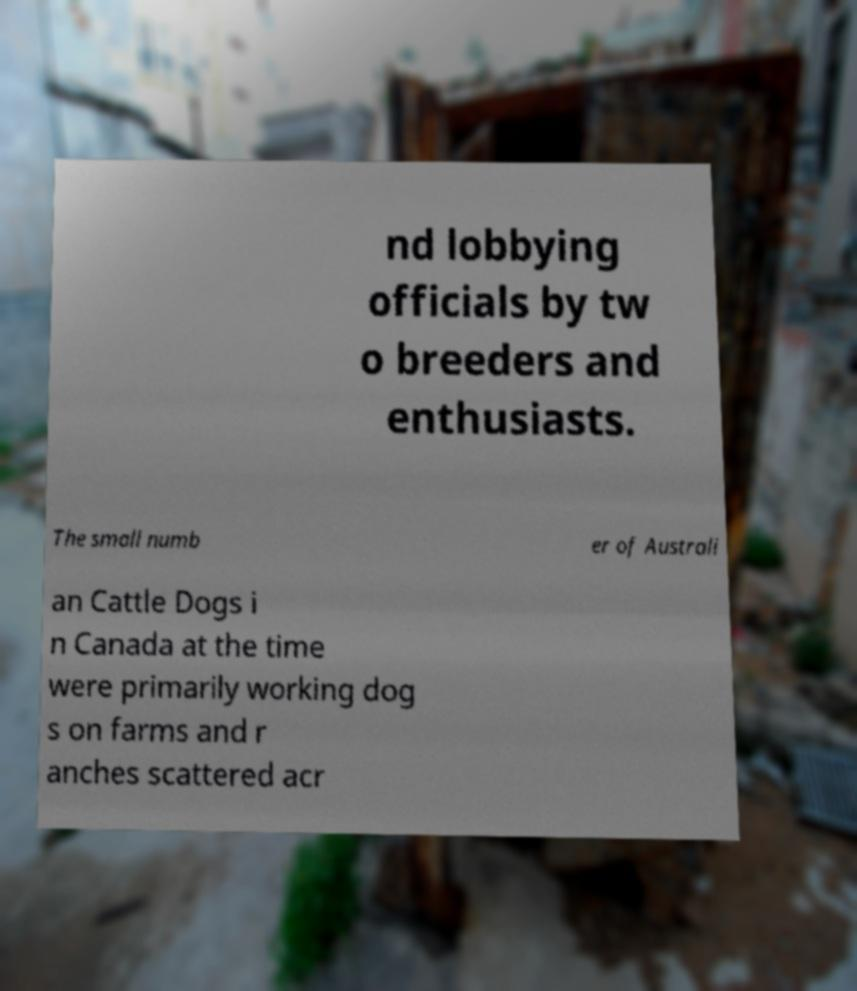What messages or text are displayed in this image? I need them in a readable, typed format. nd lobbying officials by tw o breeders and enthusiasts. The small numb er of Australi an Cattle Dogs i n Canada at the time were primarily working dog s on farms and r anches scattered acr 